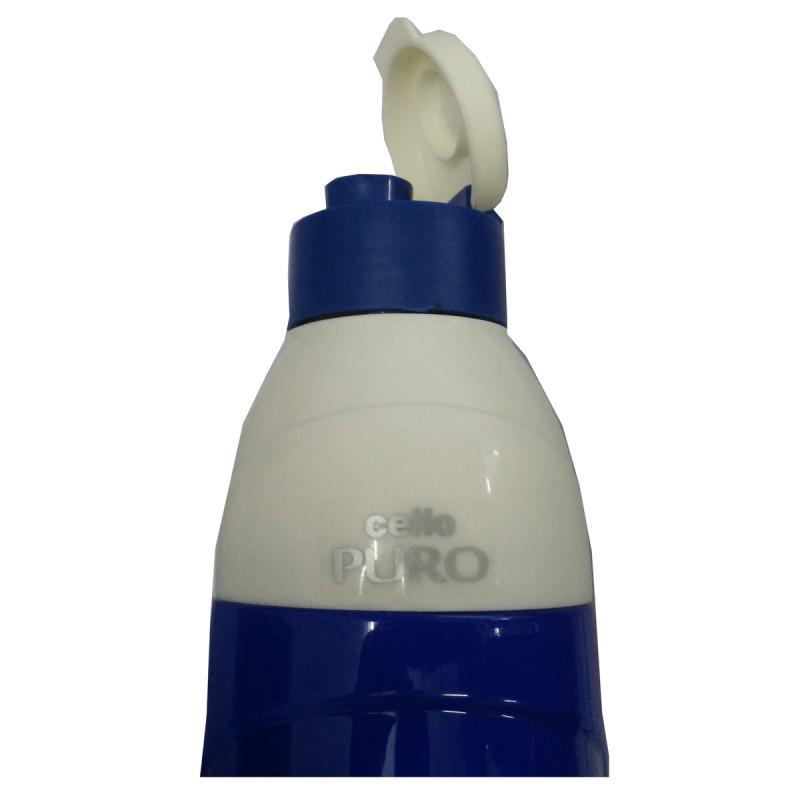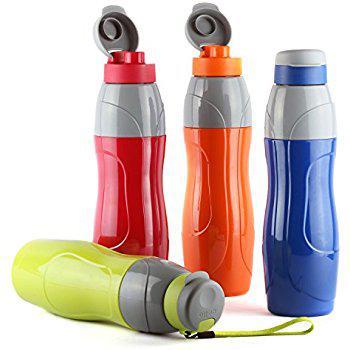The first image is the image on the left, the second image is the image on the right. Analyze the images presented: Is the assertion "There are exactly 10 bottles" valid? Answer yes or no. No. 